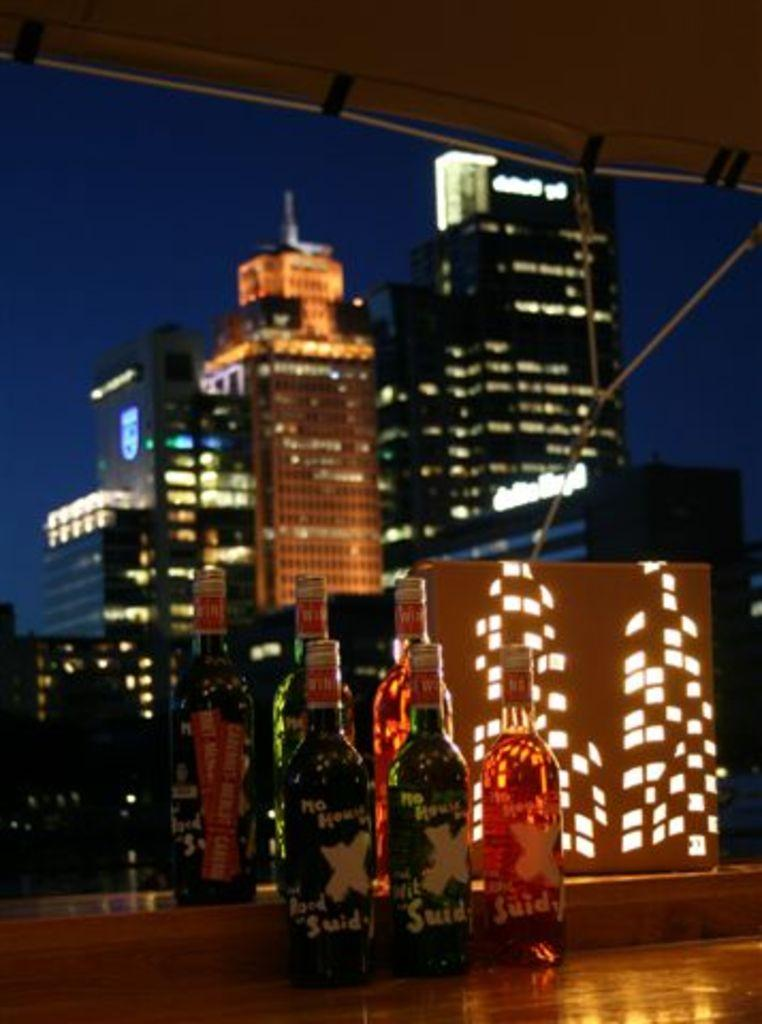<image>
Give a short and clear explanation of the subsequent image. A large X marks the set of bottles that sit in front of a city scape. 